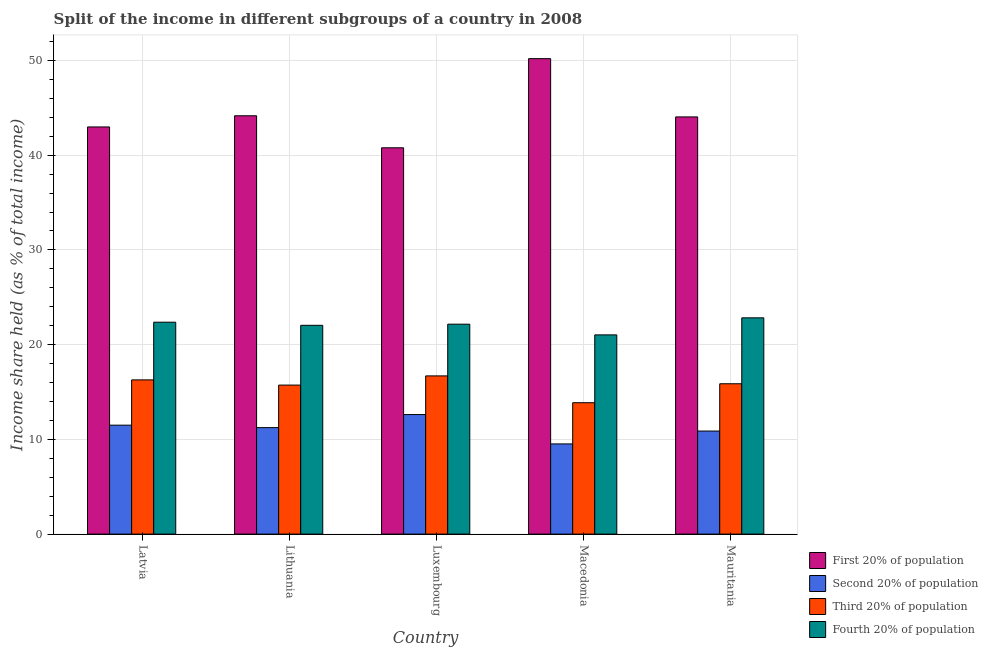What is the label of the 3rd group of bars from the left?
Your answer should be compact. Luxembourg. Across all countries, what is the maximum share of the income held by fourth 20% of the population?
Offer a very short reply. 22.83. Across all countries, what is the minimum share of the income held by fourth 20% of the population?
Offer a terse response. 21.03. In which country was the share of the income held by second 20% of the population maximum?
Give a very brief answer. Luxembourg. In which country was the share of the income held by third 20% of the population minimum?
Make the answer very short. Macedonia. What is the total share of the income held by fourth 20% of the population in the graph?
Give a very brief answer. 110.43. What is the difference between the share of the income held by fourth 20% of the population in Latvia and that in Macedonia?
Provide a succinct answer. 1.34. What is the difference between the share of the income held by third 20% of the population in Luxembourg and the share of the income held by first 20% of the population in Lithuania?
Your answer should be compact. -27.46. What is the average share of the income held by fourth 20% of the population per country?
Give a very brief answer. 22.09. What is the difference between the share of the income held by fourth 20% of the population and share of the income held by third 20% of the population in Luxembourg?
Offer a very short reply. 5.46. What is the ratio of the share of the income held by second 20% of the population in Macedonia to that in Mauritania?
Your response must be concise. 0.87. Is the share of the income held by second 20% of the population in Lithuania less than that in Mauritania?
Your answer should be very brief. No. What is the difference between the highest and the second highest share of the income held by fourth 20% of the population?
Make the answer very short. 0.46. What is the difference between the highest and the lowest share of the income held by third 20% of the population?
Provide a short and direct response. 2.83. In how many countries, is the share of the income held by fourth 20% of the population greater than the average share of the income held by fourth 20% of the population taken over all countries?
Make the answer very short. 3. Is the sum of the share of the income held by third 20% of the population in Latvia and Luxembourg greater than the maximum share of the income held by first 20% of the population across all countries?
Give a very brief answer. No. Is it the case that in every country, the sum of the share of the income held by fourth 20% of the population and share of the income held by third 20% of the population is greater than the sum of share of the income held by second 20% of the population and share of the income held by first 20% of the population?
Give a very brief answer. No. What does the 3rd bar from the left in Macedonia represents?
Your answer should be very brief. Third 20% of population. What does the 3rd bar from the right in Luxembourg represents?
Provide a succinct answer. Second 20% of population. Is it the case that in every country, the sum of the share of the income held by first 20% of the population and share of the income held by second 20% of the population is greater than the share of the income held by third 20% of the population?
Make the answer very short. Yes. Are all the bars in the graph horizontal?
Ensure brevity in your answer.  No. How many countries are there in the graph?
Give a very brief answer. 5. What is the difference between two consecutive major ticks on the Y-axis?
Keep it short and to the point. 10. Are the values on the major ticks of Y-axis written in scientific E-notation?
Make the answer very short. No. What is the title of the graph?
Provide a succinct answer. Split of the income in different subgroups of a country in 2008. Does "Management rating" appear as one of the legend labels in the graph?
Offer a very short reply. No. What is the label or title of the Y-axis?
Offer a very short reply. Income share held (as % of total income). What is the Income share held (as % of total income) in First 20% of population in Latvia?
Make the answer very short. 42.98. What is the Income share held (as % of total income) in Third 20% of population in Latvia?
Make the answer very short. 16.28. What is the Income share held (as % of total income) of Fourth 20% of population in Latvia?
Your answer should be very brief. 22.37. What is the Income share held (as % of total income) in First 20% of population in Lithuania?
Offer a very short reply. 44.16. What is the Income share held (as % of total income) in Second 20% of population in Lithuania?
Make the answer very short. 11.24. What is the Income share held (as % of total income) of Third 20% of population in Lithuania?
Your answer should be compact. 15.73. What is the Income share held (as % of total income) of Fourth 20% of population in Lithuania?
Your answer should be very brief. 22.04. What is the Income share held (as % of total income) in First 20% of population in Luxembourg?
Your answer should be compact. 40.78. What is the Income share held (as % of total income) of Second 20% of population in Luxembourg?
Provide a succinct answer. 12.62. What is the Income share held (as % of total income) of Third 20% of population in Luxembourg?
Your answer should be compact. 16.7. What is the Income share held (as % of total income) in Fourth 20% of population in Luxembourg?
Ensure brevity in your answer.  22.16. What is the Income share held (as % of total income) in First 20% of population in Macedonia?
Offer a terse response. 50.19. What is the Income share held (as % of total income) of Second 20% of population in Macedonia?
Give a very brief answer. 9.52. What is the Income share held (as % of total income) of Third 20% of population in Macedonia?
Keep it short and to the point. 13.87. What is the Income share held (as % of total income) of Fourth 20% of population in Macedonia?
Offer a terse response. 21.03. What is the Income share held (as % of total income) of First 20% of population in Mauritania?
Ensure brevity in your answer.  44.04. What is the Income share held (as % of total income) in Second 20% of population in Mauritania?
Your response must be concise. 10.88. What is the Income share held (as % of total income) of Third 20% of population in Mauritania?
Your answer should be compact. 15.87. What is the Income share held (as % of total income) of Fourth 20% of population in Mauritania?
Offer a very short reply. 22.83. Across all countries, what is the maximum Income share held (as % of total income) in First 20% of population?
Your answer should be compact. 50.19. Across all countries, what is the maximum Income share held (as % of total income) of Second 20% of population?
Offer a terse response. 12.62. Across all countries, what is the maximum Income share held (as % of total income) in Fourth 20% of population?
Keep it short and to the point. 22.83. Across all countries, what is the minimum Income share held (as % of total income) in First 20% of population?
Your response must be concise. 40.78. Across all countries, what is the minimum Income share held (as % of total income) in Second 20% of population?
Your answer should be compact. 9.52. Across all countries, what is the minimum Income share held (as % of total income) in Third 20% of population?
Your response must be concise. 13.87. Across all countries, what is the minimum Income share held (as % of total income) of Fourth 20% of population?
Keep it short and to the point. 21.03. What is the total Income share held (as % of total income) in First 20% of population in the graph?
Your response must be concise. 222.15. What is the total Income share held (as % of total income) in Second 20% of population in the graph?
Make the answer very short. 55.76. What is the total Income share held (as % of total income) in Third 20% of population in the graph?
Offer a very short reply. 78.45. What is the total Income share held (as % of total income) of Fourth 20% of population in the graph?
Give a very brief answer. 110.43. What is the difference between the Income share held (as % of total income) in First 20% of population in Latvia and that in Lithuania?
Offer a terse response. -1.18. What is the difference between the Income share held (as % of total income) of Second 20% of population in Latvia and that in Lithuania?
Provide a succinct answer. 0.26. What is the difference between the Income share held (as % of total income) of Third 20% of population in Latvia and that in Lithuania?
Provide a succinct answer. 0.55. What is the difference between the Income share held (as % of total income) in Fourth 20% of population in Latvia and that in Lithuania?
Your answer should be very brief. 0.33. What is the difference between the Income share held (as % of total income) of First 20% of population in Latvia and that in Luxembourg?
Provide a succinct answer. 2.2. What is the difference between the Income share held (as % of total income) in Second 20% of population in Latvia and that in Luxembourg?
Keep it short and to the point. -1.12. What is the difference between the Income share held (as % of total income) in Third 20% of population in Latvia and that in Luxembourg?
Provide a succinct answer. -0.42. What is the difference between the Income share held (as % of total income) of Fourth 20% of population in Latvia and that in Luxembourg?
Make the answer very short. 0.21. What is the difference between the Income share held (as % of total income) in First 20% of population in Latvia and that in Macedonia?
Your answer should be very brief. -7.21. What is the difference between the Income share held (as % of total income) of Second 20% of population in Latvia and that in Macedonia?
Your answer should be compact. 1.98. What is the difference between the Income share held (as % of total income) of Third 20% of population in Latvia and that in Macedonia?
Ensure brevity in your answer.  2.41. What is the difference between the Income share held (as % of total income) of Fourth 20% of population in Latvia and that in Macedonia?
Ensure brevity in your answer.  1.34. What is the difference between the Income share held (as % of total income) in First 20% of population in Latvia and that in Mauritania?
Offer a very short reply. -1.06. What is the difference between the Income share held (as % of total income) of Second 20% of population in Latvia and that in Mauritania?
Give a very brief answer. 0.62. What is the difference between the Income share held (as % of total income) in Third 20% of population in Latvia and that in Mauritania?
Give a very brief answer. 0.41. What is the difference between the Income share held (as % of total income) in Fourth 20% of population in Latvia and that in Mauritania?
Offer a very short reply. -0.46. What is the difference between the Income share held (as % of total income) in First 20% of population in Lithuania and that in Luxembourg?
Provide a succinct answer. 3.38. What is the difference between the Income share held (as % of total income) of Second 20% of population in Lithuania and that in Luxembourg?
Ensure brevity in your answer.  -1.38. What is the difference between the Income share held (as % of total income) in Third 20% of population in Lithuania and that in Luxembourg?
Your answer should be very brief. -0.97. What is the difference between the Income share held (as % of total income) in Fourth 20% of population in Lithuania and that in Luxembourg?
Ensure brevity in your answer.  -0.12. What is the difference between the Income share held (as % of total income) of First 20% of population in Lithuania and that in Macedonia?
Make the answer very short. -6.03. What is the difference between the Income share held (as % of total income) in Second 20% of population in Lithuania and that in Macedonia?
Offer a very short reply. 1.72. What is the difference between the Income share held (as % of total income) of Third 20% of population in Lithuania and that in Macedonia?
Provide a succinct answer. 1.86. What is the difference between the Income share held (as % of total income) of First 20% of population in Lithuania and that in Mauritania?
Provide a succinct answer. 0.12. What is the difference between the Income share held (as % of total income) in Second 20% of population in Lithuania and that in Mauritania?
Make the answer very short. 0.36. What is the difference between the Income share held (as % of total income) of Third 20% of population in Lithuania and that in Mauritania?
Give a very brief answer. -0.14. What is the difference between the Income share held (as % of total income) of Fourth 20% of population in Lithuania and that in Mauritania?
Your answer should be very brief. -0.79. What is the difference between the Income share held (as % of total income) in First 20% of population in Luxembourg and that in Macedonia?
Offer a terse response. -9.41. What is the difference between the Income share held (as % of total income) of Third 20% of population in Luxembourg and that in Macedonia?
Provide a short and direct response. 2.83. What is the difference between the Income share held (as % of total income) of Fourth 20% of population in Luxembourg and that in Macedonia?
Your answer should be very brief. 1.13. What is the difference between the Income share held (as % of total income) of First 20% of population in Luxembourg and that in Mauritania?
Your answer should be compact. -3.26. What is the difference between the Income share held (as % of total income) in Second 20% of population in Luxembourg and that in Mauritania?
Provide a short and direct response. 1.74. What is the difference between the Income share held (as % of total income) of Third 20% of population in Luxembourg and that in Mauritania?
Offer a terse response. 0.83. What is the difference between the Income share held (as % of total income) of Fourth 20% of population in Luxembourg and that in Mauritania?
Ensure brevity in your answer.  -0.67. What is the difference between the Income share held (as % of total income) in First 20% of population in Macedonia and that in Mauritania?
Provide a succinct answer. 6.15. What is the difference between the Income share held (as % of total income) in Second 20% of population in Macedonia and that in Mauritania?
Offer a terse response. -1.36. What is the difference between the Income share held (as % of total income) in Third 20% of population in Macedonia and that in Mauritania?
Your response must be concise. -2. What is the difference between the Income share held (as % of total income) in Fourth 20% of population in Macedonia and that in Mauritania?
Provide a short and direct response. -1.8. What is the difference between the Income share held (as % of total income) in First 20% of population in Latvia and the Income share held (as % of total income) in Second 20% of population in Lithuania?
Keep it short and to the point. 31.74. What is the difference between the Income share held (as % of total income) in First 20% of population in Latvia and the Income share held (as % of total income) in Third 20% of population in Lithuania?
Provide a succinct answer. 27.25. What is the difference between the Income share held (as % of total income) in First 20% of population in Latvia and the Income share held (as % of total income) in Fourth 20% of population in Lithuania?
Your answer should be very brief. 20.94. What is the difference between the Income share held (as % of total income) in Second 20% of population in Latvia and the Income share held (as % of total income) in Third 20% of population in Lithuania?
Give a very brief answer. -4.23. What is the difference between the Income share held (as % of total income) in Second 20% of population in Latvia and the Income share held (as % of total income) in Fourth 20% of population in Lithuania?
Provide a short and direct response. -10.54. What is the difference between the Income share held (as % of total income) of Third 20% of population in Latvia and the Income share held (as % of total income) of Fourth 20% of population in Lithuania?
Your answer should be compact. -5.76. What is the difference between the Income share held (as % of total income) of First 20% of population in Latvia and the Income share held (as % of total income) of Second 20% of population in Luxembourg?
Give a very brief answer. 30.36. What is the difference between the Income share held (as % of total income) in First 20% of population in Latvia and the Income share held (as % of total income) in Third 20% of population in Luxembourg?
Make the answer very short. 26.28. What is the difference between the Income share held (as % of total income) of First 20% of population in Latvia and the Income share held (as % of total income) of Fourth 20% of population in Luxembourg?
Give a very brief answer. 20.82. What is the difference between the Income share held (as % of total income) in Second 20% of population in Latvia and the Income share held (as % of total income) in Fourth 20% of population in Luxembourg?
Keep it short and to the point. -10.66. What is the difference between the Income share held (as % of total income) in Third 20% of population in Latvia and the Income share held (as % of total income) in Fourth 20% of population in Luxembourg?
Offer a very short reply. -5.88. What is the difference between the Income share held (as % of total income) in First 20% of population in Latvia and the Income share held (as % of total income) in Second 20% of population in Macedonia?
Provide a succinct answer. 33.46. What is the difference between the Income share held (as % of total income) in First 20% of population in Latvia and the Income share held (as % of total income) in Third 20% of population in Macedonia?
Ensure brevity in your answer.  29.11. What is the difference between the Income share held (as % of total income) in First 20% of population in Latvia and the Income share held (as % of total income) in Fourth 20% of population in Macedonia?
Offer a very short reply. 21.95. What is the difference between the Income share held (as % of total income) of Second 20% of population in Latvia and the Income share held (as % of total income) of Third 20% of population in Macedonia?
Provide a short and direct response. -2.37. What is the difference between the Income share held (as % of total income) of Second 20% of population in Latvia and the Income share held (as % of total income) of Fourth 20% of population in Macedonia?
Give a very brief answer. -9.53. What is the difference between the Income share held (as % of total income) of Third 20% of population in Latvia and the Income share held (as % of total income) of Fourth 20% of population in Macedonia?
Your answer should be very brief. -4.75. What is the difference between the Income share held (as % of total income) in First 20% of population in Latvia and the Income share held (as % of total income) in Second 20% of population in Mauritania?
Your response must be concise. 32.1. What is the difference between the Income share held (as % of total income) of First 20% of population in Latvia and the Income share held (as % of total income) of Third 20% of population in Mauritania?
Your answer should be very brief. 27.11. What is the difference between the Income share held (as % of total income) in First 20% of population in Latvia and the Income share held (as % of total income) in Fourth 20% of population in Mauritania?
Make the answer very short. 20.15. What is the difference between the Income share held (as % of total income) in Second 20% of population in Latvia and the Income share held (as % of total income) in Third 20% of population in Mauritania?
Provide a short and direct response. -4.37. What is the difference between the Income share held (as % of total income) of Second 20% of population in Latvia and the Income share held (as % of total income) of Fourth 20% of population in Mauritania?
Offer a terse response. -11.33. What is the difference between the Income share held (as % of total income) in Third 20% of population in Latvia and the Income share held (as % of total income) in Fourth 20% of population in Mauritania?
Provide a short and direct response. -6.55. What is the difference between the Income share held (as % of total income) of First 20% of population in Lithuania and the Income share held (as % of total income) of Second 20% of population in Luxembourg?
Make the answer very short. 31.54. What is the difference between the Income share held (as % of total income) in First 20% of population in Lithuania and the Income share held (as % of total income) in Third 20% of population in Luxembourg?
Your answer should be very brief. 27.46. What is the difference between the Income share held (as % of total income) in First 20% of population in Lithuania and the Income share held (as % of total income) in Fourth 20% of population in Luxembourg?
Keep it short and to the point. 22. What is the difference between the Income share held (as % of total income) of Second 20% of population in Lithuania and the Income share held (as % of total income) of Third 20% of population in Luxembourg?
Provide a short and direct response. -5.46. What is the difference between the Income share held (as % of total income) of Second 20% of population in Lithuania and the Income share held (as % of total income) of Fourth 20% of population in Luxembourg?
Provide a short and direct response. -10.92. What is the difference between the Income share held (as % of total income) in Third 20% of population in Lithuania and the Income share held (as % of total income) in Fourth 20% of population in Luxembourg?
Offer a terse response. -6.43. What is the difference between the Income share held (as % of total income) in First 20% of population in Lithuania and the Income share held (as % of total income) in Second 20% of population in Macedonia?
Provide a succinct answer. 34.64. What is the difference between the Income share held (as % of total income) of First 20% of population in Lithuania and the Income share held (as % of total income) of Third 20% of population in Macedonia?
Provide a short and direct response. 30.29. What is the difference between the Income share held (as % of total income) of First 20% of population in Lithuania and the Income share held (as % of total income) of Fourth 20% of population in Macedonia?
Offer a very short reply. 23.13. What is the difference between the Income share held (as % of total income) of Second 20% of population in Lithuania and the Income share held (as % of total income) of Third 20% of population in Macedonia?
Your response must be concise. -2.63. What is the difference between the Income share held (as % of total income) of Second 20% of population in Lithuania and the Income share held (as % of total income) of Fourth 20% of population in Macedonia?
Make the answer very short. -9.79. What is the difference between the Income share held (as % of total income) in Third 20% of population in Lithuania and the Income share held (as % of total income) in Fourth 20% of population in Macedonia?
Give a very brief answer. -5.3. What is the difference between the Income share held (as % of total income) of First 20% of population in Lithuania and the Income share held (as % of total income) of Second 20% of population in Mauritania?
Provide a short and direct response. 33.28. What is the difference between the Income share held (as % of total income) in First 20% of population in Lithuania and the Income share held (as % of total income) in Third 20% of population in Mauritania?
Your response must be concise. 28.29. What is the difference between the Income share held (as % of total income) in First 20% of population in Lithuania and the Income share held (as % of total income) in Fourth 20% of population in Mauritania?
Give a very brief answer. 21.33. What is the difference between the Income share held (as % of total income) in Second 20% of population in Lithuania and the Income share held (as % of total income) in Third 20% of population in Mauritania?
Offer a very short reply. -4.63. What is the difference between the Income share held (as % of total income) in Second 20% of population in Lithuania and the Income share held (as % of total income) in Fourth 20% of population in Mauritania?
Provide a succinct answer. -11.59. What is the difference between the Income share held (as % of total income) of Third 20% of population in Lithuania and the Income share held (as % of total income) of Fourth 20% of population in Mauritania?
Your response must be concise. -7.1. What is the difference between the Income share held (as % of total income) of First 20% of population in Luxembourg and the Income share held (as % of total income) of Second 20% of population in Macedonia?
Make the answer very short. 31.26. What is the difference between the Income share held (as % of total income) of First 20% of population in Luxembourg and the Income share held (as % of total income) of Third 20% of population in Macedonia?
Offer a very short reply. 26.91. What is the difference between the Income share held (as % of total income) in First 20% of population in Luxembourg and the Income share held (as % of total income) in Fourth 20% of population in Macedonia?
Offer a very short reply. 19.75. What is the difference between the Income share held (as % of total income) of Second 20% of population in Luxembourg and the Income share held (as % of total income) of Third 20% of population in Macedonia?
Ensure brevity in your answer.  -1.25. What is the difference between the Income share held (as % of total income) of Second 20% of population in Luxembourg and the Income share held (as % of total income) of Fourth 20% of population in Macedonia?
Give a very brief answer. -8.41. What is the difference between the Income share held (as % of total income) in Third 20% of population in Luxembourg and the Income share held (as % of total income) in Fourth 20% of population in Macedonia?
Keep it short and to the point. -4.33. What is the difference between the Income share held (as % of total income) of First 20% of population in Luxembourg and the Income share held (as % of total income) of Second 20% of population in Mauritania?
Your answer should be compact. 29.9. What is the difference between the Income share held (as % of total income) of First 20% of population in Luxembourg and the Income share held (as % of total income) of Third 20% of population in Mauritania?
Make the answer very short. 24.91. What is the difference between the Income share held (as % of total income) in First 20% of population in Luxembourg and the Income share held (as % of total income) in Fourth 20% of population in Mauritania?
Your response must be concise. 17.95. What is the difference between the Income share held (as % of total income) of Second 20% of population in Luxembourg and the Income share held (as % of total income) of Third 20% of population in Mauritania?
Keep it short and to the point. -3.25. What is the difference between the Income share held (as % of total income) of Second 20% of population in Luxembourg and the Income share held (as % of total income) of Fourth 20% of population in Mauritania?
Give a very brief answer. -10.21. What is the difference between the Income share held (as % of total income) of Third 20% of population in Luxembourg and the Income share held (as % of total income) of Fourth 20% of population in Mauritania?
Offer a very short reply. -6.13. What is the difference between the Income share held (as % of total income) of First 20% of population in Macedonia and the Income share held (as % of total income) of Second 20% of population in Mauritania?
Make the answer very short. 39.31. What is the difference between the Income share held (as % of total income) in First 20% of population in Macedonia and the Income share held (as % of total income) in Third 20% of population in Mauritania?
Offer a terse response. 34.32. What is the difference between the Income share held (as % of total income) of First 20% of population in Macedonia and the Income share held (as % of total income) of Fourth 20% of population in Mauritania?
Your response must be concise. 27.36. What is the difference between the Income share held (as % of total income) of Second 20% of population in Macedonia and the Income share held (as % of total income) of Third 20% of population in Mauritania?
Keep it short and to the point. -6.35. What is the difference between the Income share held (as % of total income) of Second 20% of population in Macedonia and the Income share held (as % of total income) of Fourth 20% of population in Mauritania?
Offer a very short reply. -13.31. What is the difference between the Income share held (as % of total income) of Third 20% of population in Macedonia and the Income share held (as % of total income) of Fourth 20% of population in Mauritania?
Provide a succinct answer. -8.96. What is the average Income share held (as % of total income) in First 20% of population per country?
Offer a very short reply. 44.43. What is the average Income share held (as % of total income) of Second 20% of population per country?
Your answer should be very brief. 11.15. What is the average Income share held (as % of total income) of Third 20% of population per country?
Offer a terse response. 15.69. What is the average Income share held (as % of total income) of Fourth 20% of population per country?
Your answer should be compact. 22.09. What is the difference between the Income share held (as % of total income) of First 20% of population and Income share held (as % of total income) of Second 20% of population in Latvia?
Keep it short and to the point. 31.48. What is the difference between the Income share held (as % of total income) of First 20% of population and Income share held (as % of total income) of Third 20% of population in Latvia?
Your answer should be compact. 26.7. What is the difference between the Income share held (as % of total income) in First 20% of population and Income share held (as % of total income) in Fourth 20% of population in Latvia?
Offer a very short reply. 20.61. What is the difference between the Income share held (as % of total income) in Second 20% of population and Income share held (as % of total income) in Third 20% of population in Latvia?
Your answer should be compact. -4.78. What is the difference between the Income share held (as % of total income) of Second 20% of population and Income share held (as % of total income) of Fourth 20% of population in Latvia?
Give a very brief answer. -10.87. What is the difference between the Income share held (as % of total income) in Third 20% of population and Income share held (as % of total income) in Fourth 20% of population in Latvia?
Your answer should be compact. -6.09. What is the difference between the Income share held (as % of total income) of First 20% of population and Income share held (as % of total income) of Second 20% of population in Lithuania?
Make the answer very short. 32.92. What is the difference between the Income share held (as % of total income) in First 20% of population and Income share held (as % of total income) in Third 20% of population in Lithuania?
Provide a short and direct response. 28.43. What is the difference between the Income share held (as % of total income) of First 20% of population and Income share held (as % of total income) of Fourth 20% of population in Lithuania?
Provide a short and direct response. 22.12. What is the difference between the Income share held (as % of total income) of Second 20% of population and Income share held (as % of total income) of Third 20% of population in Lithuania?
Provide a succinct answer. -4.49. What is the difference between the Income share held (as % of total income) in Second 20% of population and Income share held (as % of total income) in Fourth 20% of population in Lithuania?
Make the answer very short. -10.8. What is the difference between the Income share held (as % of total income) in Third 20% of population and Income share held (as % of total income) in Fourth 20% of population in Lithuania?
Give a very brief answer. -6.31. What is the difference between the Income share held (as % of total income) in First 20% of population and Income share held (as % of total income) in Second 20% of population in Luxembourg?
Provide a short and direct response. 28.16. What is the difference between the Income share held (as % of total income) of First 20% of population and Income share held (as % of total income) of Third 20% of population in Luxembourg?
Ensure brevity in your answer.  24.08. What is the difference between the Income share held (as % of total income) in First 20% of population and Income share held (as % of total income) in Fourth 20% of population in Luxembourg?
Offer a very short reply. 18.62. What is the difference between the Income share held (as % of total income) in Second 20% of population and Income share held (as % of total income) in Third 20% of population in Luxembourg?
Make the answer very short. -4.08. What is the difference between the Income share held (as % of total income) in Second 20% of population and Income share held (as % of total income) in Fourth 20% of population in Luxembourg?
Your response must be concise. -9.54. What is the difference between the Income share held (as % of total income) of Third 20% of population and Income share held (as % of total income) of Fourth 20% of population in Luxembourg?
Make the answer very short. -5.46. What is the difference between the Income share held (as % of total income) in First 20% of population and Income share held (as % of total income) in Second 20% of population in Macedonia?
Offer a very short reply. 40.67. What is the difference between the Income share held (as % of total income) of First 20% of population and Income share held (as % of total income) of Third 20% of population in Macedonia?
Offer a terse response. 36.32. What is the difference between the Income share held (as % of total income) in First 20% of population and Income share held (as % of total income) in Fourth 20% of population in Macedonia?
Provide a succinct answer. 29.16. What is the difference between the Income share held (as % of total income) of Second 20% of population and Income share held (as % of total income) of Third 20% of population in Macedonia?
Offer a very short reply. -4.35. What is the difference between the Income share held (as % of total income) of Second 20% of population and Income share held (as % of total income) of Fourth 20% of population in Macedonia?
Your response must be concise. -11.51. What is the difference between the Income share held (as % of total income) in Third 20% of population and Income share held (as % of total income) in Fourth 20% of population in Macedonia?
Offer a terse response. -7.16. What is the difference between the Income share held (as % of total income) of First 20% of population and Income share held (as % of total income) of Second 20% of population in Mauritania?
Your response must be concise. 33.16. What is the difference between the Income share held (as % of total income) of First 20% of population and Income share held (as % of total income) of Third 20% of population in Mauritania?
Make the answer very short. 28.17. What is the difference between the Income share held (as % of total income) in First 20% of population and Income share held (as % of total income) in Fourth 20% of population in Mauritania?
Your answer should be compact. 21.21. What is the difference between the Income share held (as % of total income) in Second 20% of population and Income share held (as % of total income) in Third 20% of population in Mauritania?
Make the answer very short. -4.99. What is the difference between the Income share held (as % of total income) of Second 20% of population and Income share held (as % of total income) of Fourth 20% of population in Mauritania?
Ensure brevity in your answer.  -11.95. What is the difference between the Income share held (as % of total income) in Third 20% of population and Income share held (as % of total income) in Fourth 20% of population in Mauritania?
Your answer should be very brief. -6.96. What is the ratio of the Income share held (as % of total income) of First 20% of population in Latvia to that in Lithuania?
Provide a succinct answer. 0.97. What is the ratio of the Income share held (as % of total income) of Second 20% of population in Latvia to that in Lithuania?
Keep it short and to the point. 1.02. What is the ratio of the Income share held (as % of total income) of Third 20% of population in Latvia to that in Lithuania?
Make the answer very short. 1.03. What is the ratio of the Income share held (as % of total income) of Fourth 20% of population in Latvia to that in Lithuania?
Offer a very short reply. 1.01. What is the ratio of the Income share held (as % of total income) of First 20% of population in Latvia to that in Luxembourg?
Make the answer very short. 1.05. What is the ratio of the Income share held (as % of total income) in Second 20% of population in Latvia to that in Luxembourg?
Make the answer very short. 0.91. What is the ratio of the Income share held (as % of total income) in Third 20% of population in Latvia to that in Luxembourg?
Ensure brevity in your answer.  0.97. What is the ratio of the Income share held (as % of total income) in Fourth 20% of population in Latvia to that in Luxembourg?
Offer a very short reply. 1.01. What is the ratio of the Income share held (as % of total income) of First 20% of population in Latvia to that in Macedonia?
Make the answer very short. 0.86. What is the ratio of the Income share held (as % of total income) of Second 20% of population in Latvia to that in Macedonia?
Your answer should be very brief. 1.21. What is the ratio of the Income share held (as % of total income) of Third 20% of population in Latvia to that in Macedonia?
Offer a very short reply. 1.17. What is the ratio of the Income share held (as % of total income) of Fourth 20% of population in Latvia to that in Macedonia?
Your answer should be compact. 1.06. What is the ratio of the Income share held (as % of total income) in First 20% of population in Latvia to that in Mauritania?
Provide a succinct answer. 0.98. What is the ratio of the Income share held (as % of total income) in Second 20% of population in Latvia to that in Mauritania?
Provide a succinct answer. 1.06. What is the ratio of the Income share held (as % of total income) of Third 20% of population in Latvia to that in Mauritania?
Make the answer very short. 1.03. What is the ratio of the Income share held (as % of total income) in Fourth 20% of population in Latvia to that in Mauritania?
Provide a succinct answer. 0.98. What is the ratio of the Income share held (as % of total income) of First 20% of population in Lithuania to that in Luxembourg?
Make the answer very short. 1.08. What is the ratio of the Income share held (as % of total income) of Second 20% of population in Lithuania to that in Luxembourg?
Ensure brevity in your answer.  0.89. What is the ratio of the Income share held (as % of total income) of Third 20% of population in Lithuania to that in Luxembourg?
Keep it short and to the point. 0.94. What is the ratio of the Income share held (as % of total income) in First 20% of population in Lithuania to that in Macedonia?
Give a very brief answer. 0.88. What is the ratio of the Income share held (as % of total income) in Second 20% of population in Lithuania to that in Macedonia?
Provide a short and direct response. 1.18. What is the ratio of the Income share held (as % of total income) of Third 20% of population in Lithuania to that in Macedonia?
Offer a terse response. 1.13. What is the ratio of the Income share held (as % of total income) of Fourth 20% of population in Lithuania to that in Macedonia?
Offer a terse response. 1.05. What is the ratio of the Income share held (as % of total income) of First 20% of population in Lithuania to that in Mauritania?
Your answer should be very brief. 1. What is the ratio of the Income share held (as % of total income) of Second 20% of population in Lithuania to that in Mauritania?
Give a very brief answer. 1.03. What is the ratio of the Income share held (as % of total income) in Fourth 20% of population in Lithuania to that in Mauritania?
Make the answer very short. 0.97. What is the ratio of the Income share held (as % of total income) in First 20% of population in Luxembourg to that in Macedonia?
Provide a short and direct response. 0.81. What is the ratio of the Income share held (as % of total income) of Second 20% of population in Luxembourg to that in Macedonia?
Your answer should be compact. 1.33. What is the ratio of the Income share held (as % of total income) in Third 20% of population in Luxembourg to that in Macedonia?
Offer a terse response. 1.2. What is the ratio of the Income share held (as % of total income) of Fourth 20% of population in Luxembourg to that in Macedonia?
Your answer should be compact. 1.05. What is the ratio of the Income share held (as % of total income) of First 20% of population in Luxembourg to that in Mauritania?
Ensure brevity in your answer.  0.93. What is the ratio of the Income share held (as % of total income) in Second 20% of population in Luxembourg to that in Mauritania?
Your answer should be very brief. 1.16. What is the ratio of the Income share held (as % of total income) in Third 20% of population in Luxembourg to that in Mauritania?
Provide a succinct answer. 1.05. What is the ratio of the Income share held (as % of total income) in Fourth 20% of population in Luxembourg to that in Mauritania?
Provide a succinct answer. 0.97. What is the ratio of the Income share held (as % of total income) in First 20% of population in Macedonia to that in Mauritania?
Make the answer very short. 1.14. What is the ratio of the Income share held (as % of total income) in Third 20% of population in Macedonia to that in Mauritania?
Give a very brief answer. 0.87. What is the ratio of the Income share held (as % of total income) in Fourth 20% of population in Macedonia to that in Mauritania?
Offer a terse response. 0.92. What is the difference between the highest and the second highest Income share held (as % of total income) in First 20% of population?
Your answer should be compact. 6.03. What is the difference between the highest and the second highest Income share held (as % of total income) of Second 20% of population?
Give a very brief answer. 1.12. What is the difference between the highest and the second highest Income share held (as % of total income) of Third 20% of population?
Make the answer very short. 0.42. What is the difference between the highest and the second highest Income share held (as % of total income) of Fourth 20% of population?
Make the answer very short. 0.46. What is the difference between the highest and the lowest Income share held (as % of total income) in First 20% of population?
Your answer should be very brief. 9.41. What is the difference between the highest and the lowest Income share held (as % of total income) in Second 20% of population?
Give a very brief answer. 3.1. What is the difference between the highest and the lowest Income share held (as % of total income) of Third 20% of population?
Offer a very short reply. 2.83. 